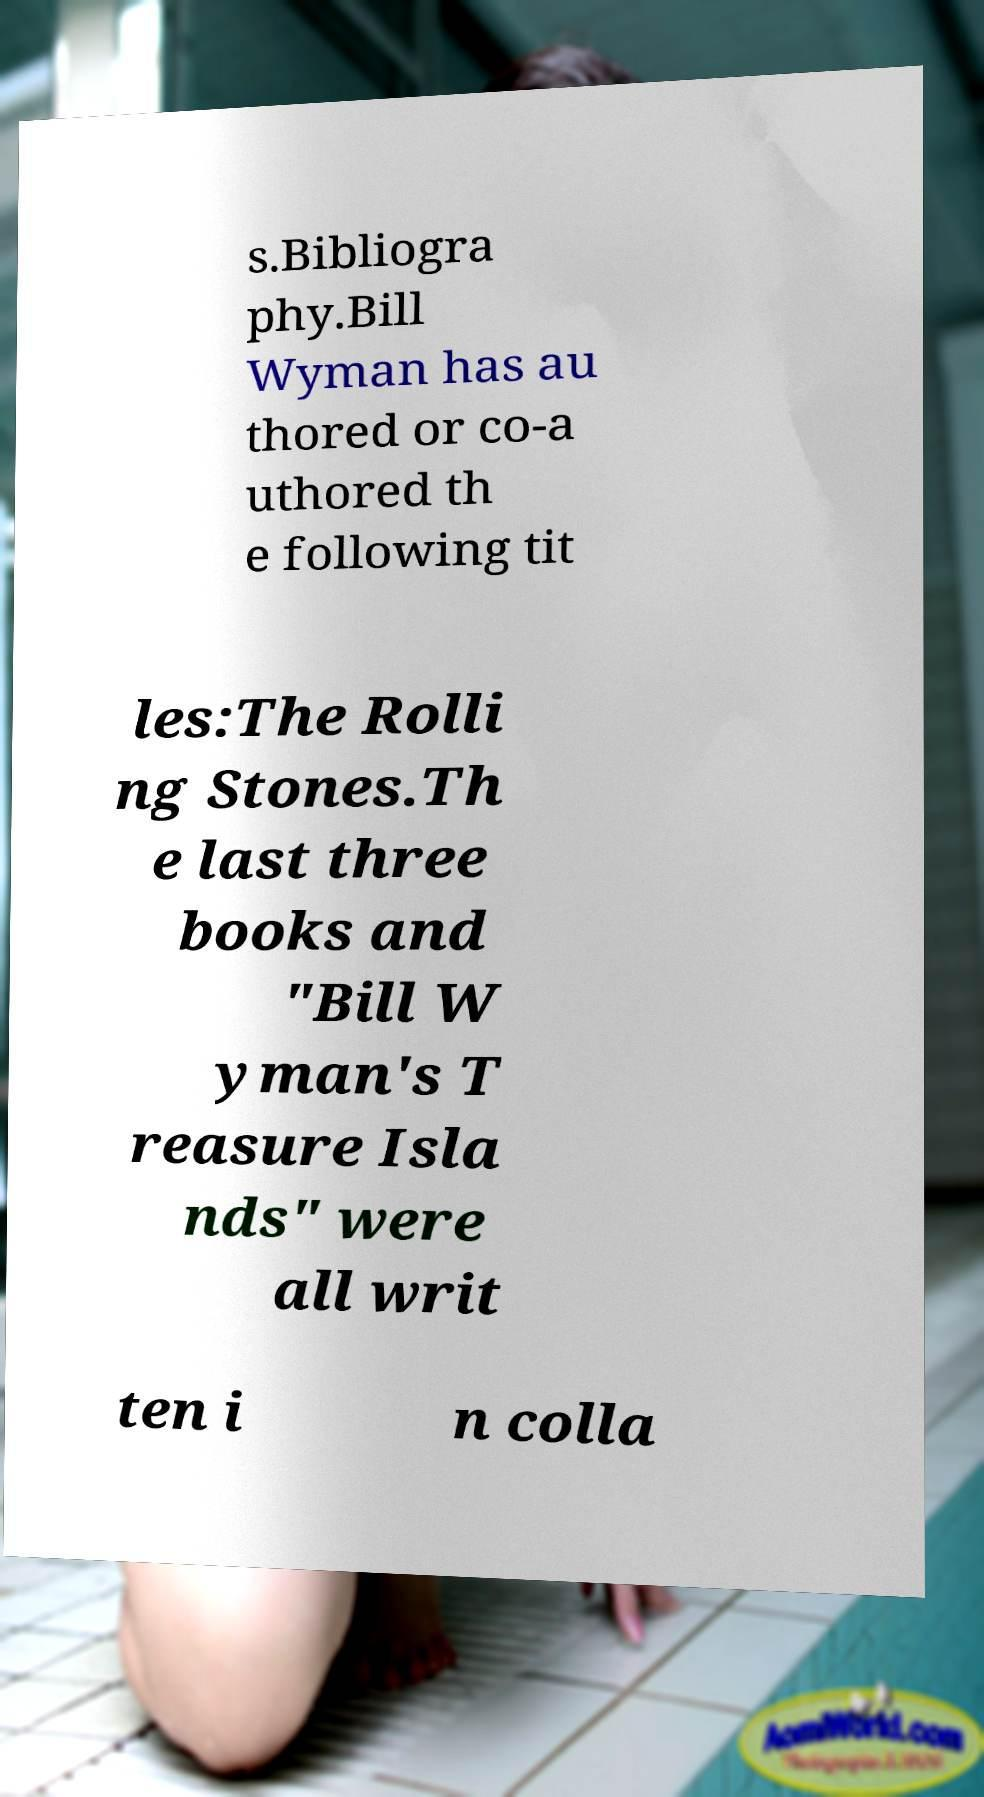Please read and relay the text visible in this image. What does it say? s.Bibliogra phy.Bill Wyman has au thored or co-a uthored th e following tit les:The Rolli ng Stones.Th e last three books and "Bill W yman's T reasure Isla nds" were all writ ten i n colla 